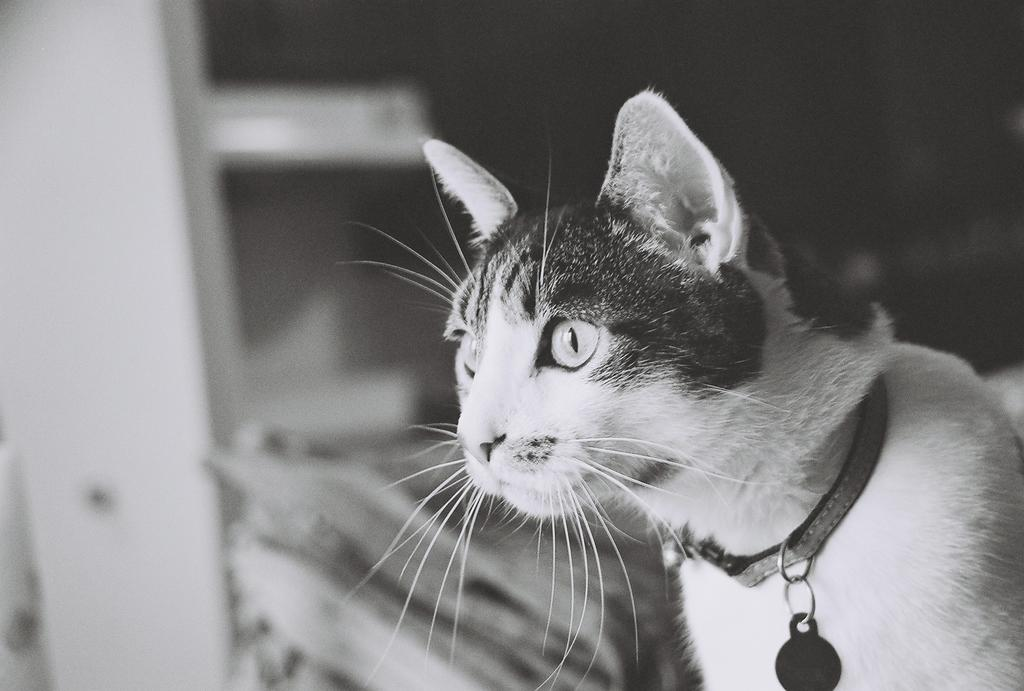What is the color scheme of the image? The image is black and white. What animal can be seen in the image? There is a cat in the image. Is the cat wearing any accessories in the image? Yes, the cat is wearing a neck chain. How would you describe the background of the image? The background of the image is blurry. What type of zinc object is present in the image? There is no zinc object present in the image. Can you describe the chair that the cat is sitting on in the image? There is no chair present in the image; the cat is not sitting on anything. 